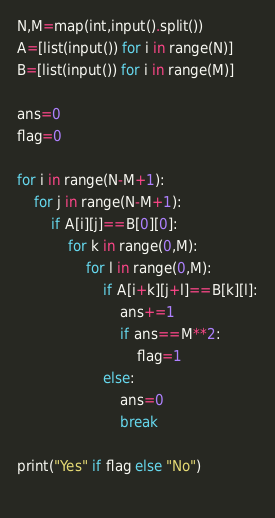Convert code to text. <code><loc_0><loc_0><loc_500><loc_500><_Python_>N,M=map(int,input().split())
A=[list(input()) for i in range(N)]
B=[list(input()) for i in range(M)]

ans=0
flag=0

for i in range(N-M+1):
    for j in range(N-M+1):
        if A[i][j]==B[0][0]:
            for k in range(0,M):
                for l in range(0,M):
                    if A[i+k][j+l]==B[k][l]:
                        ans+=1
                        if ans==M**2:
                            flag=1
                    else:
                        ans=0
                        break
    
print("Yes" if flag else "No")
                </code> 